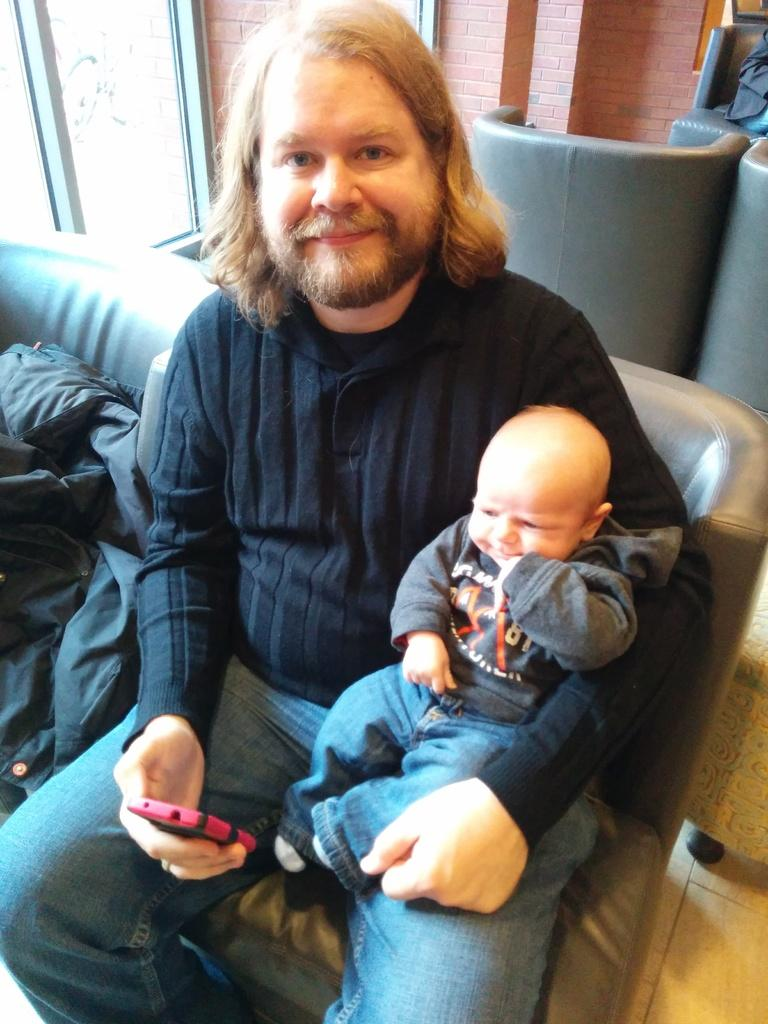Who or what is present in the image? There is a person and a baby in the image. What can be seen hanging above the baby? There is a mobile in the image. What is the person wearing? There is a jacket in the image. What type of furniture is in the image? There are chairs in the image. What architectural features can be seen in the image? There is a window and a wall in the image. What type of toy can be seen in the field in the image? There is no field or toy present in the image. 